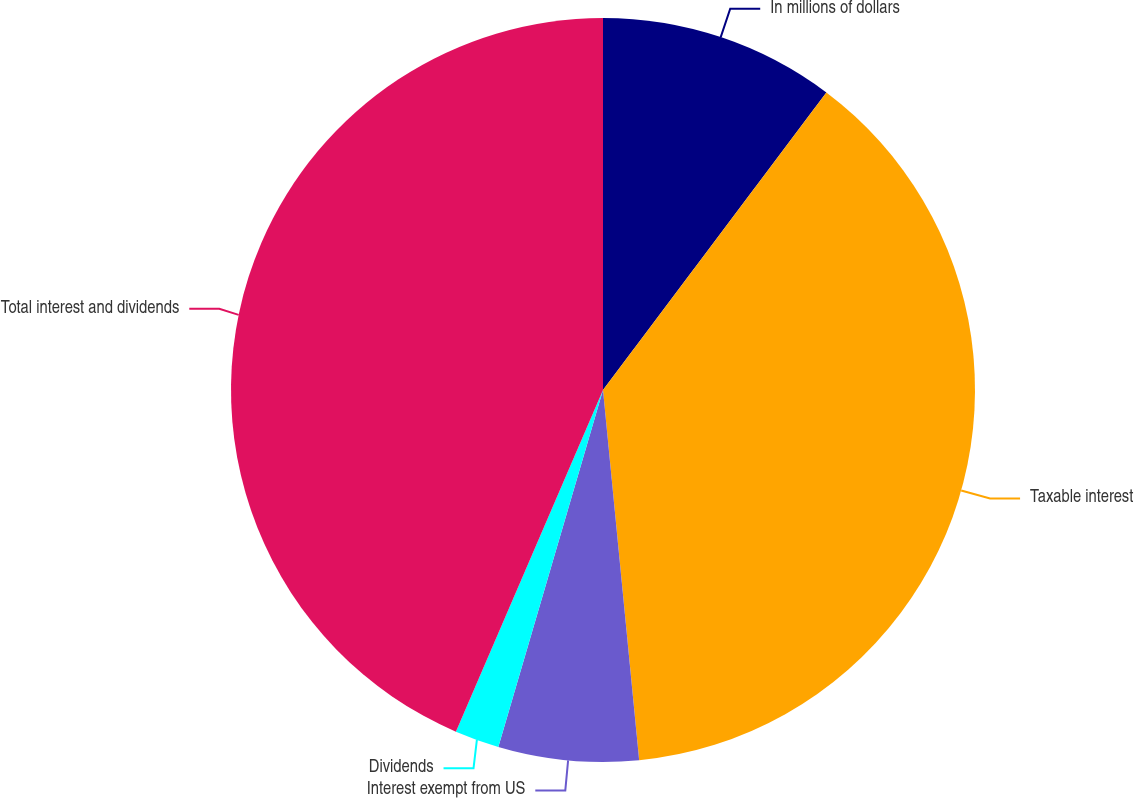<chart> <loc_0><loc_0><loc_500><loc_500><pie_chart><fcel>In millions of dollars<fcel>Taxable interest<fcel>Interest exempt from US<fcel>Dividends<fcel>Total interest and dividends<nl><fcel>10.25%<fcel>38.2%<fcel>6.09%<fcel>1.93%<fcel>43.53%<nl></chart> 